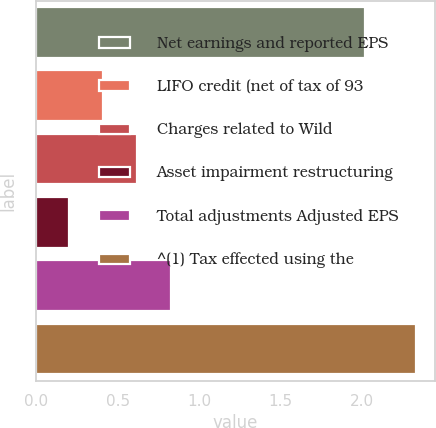Convert chart to OTSL. <chart><loc_0><loc_0><loc_500><loc_500><bar_chart><fcel>Net earnings and reported EPS<fcel>LIFO credit (net of tax of 93<fcel>Charges related to Wild<fcel>Asset impairment restructuring<fcel>Total adjustments Adjusted EPS<fcel>^(1) Tax effected using the<nl><fcel>2.02<fcel>0.41<fcel>0.62<fcel>0.2<fcel>0.83<fcel>2.33<nl></chart> 